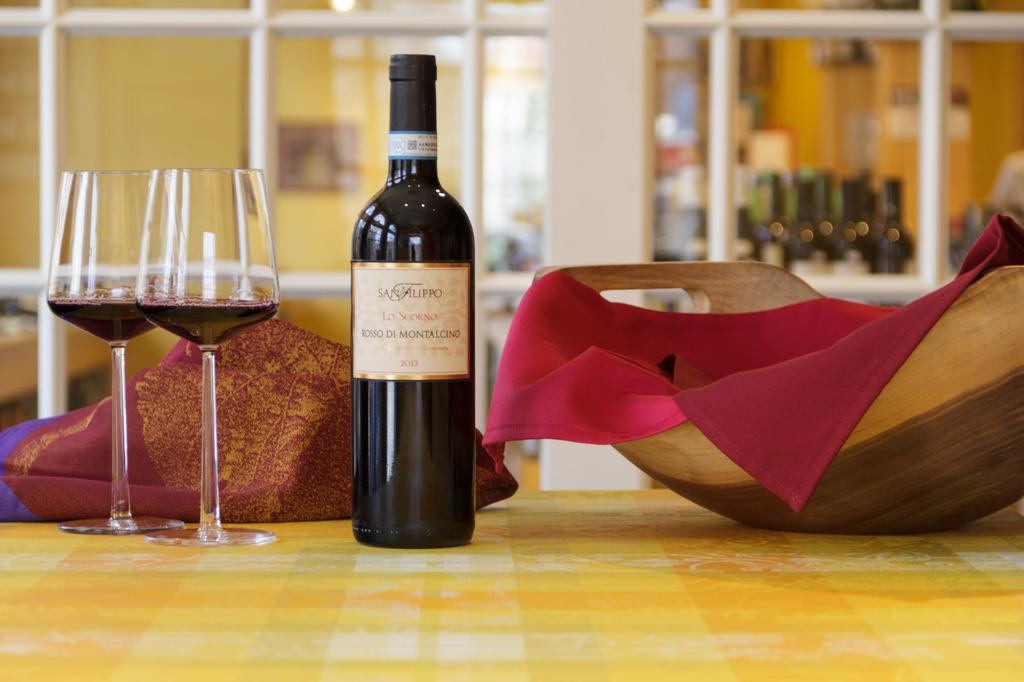<image>
Write a terse but informative summary of the picture. two glasses of red wine next to the bottle of san filippo 